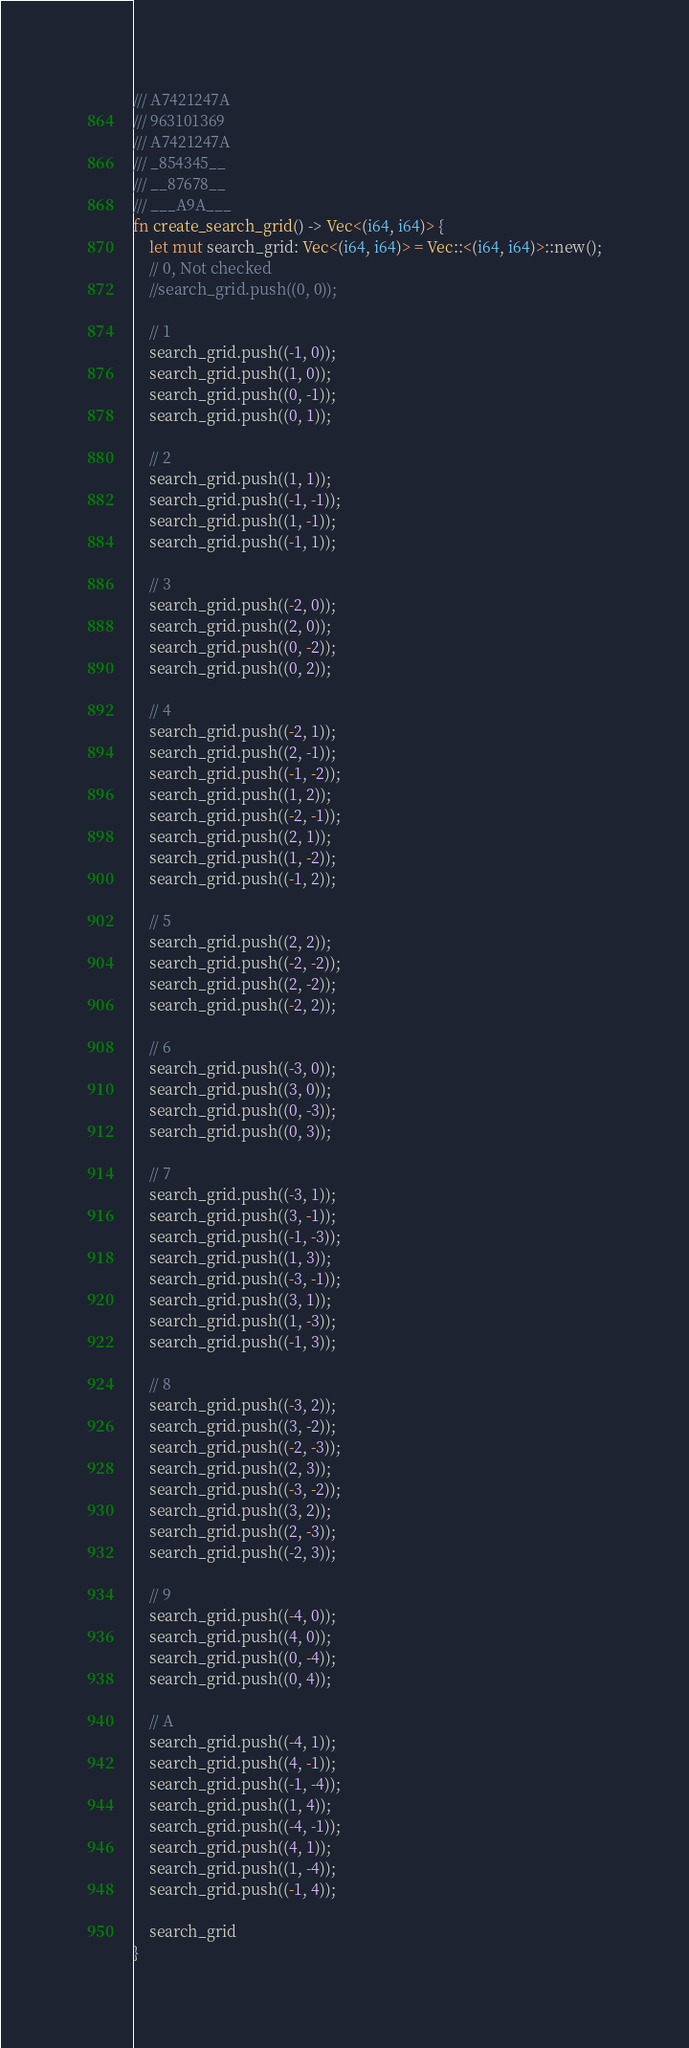Convert code to text. <code><loc_0><loc_0><loc_500><loc_500><_Rust_>/// A7421247A
/// 963101369
/// A7421247A
/// _854345__
/// __87678__
/// ___A9A___
fn create_search_grid() -> Vec<(i64, i64)> {
    let mut search_grid: Vec<(i64, i64)> = Vec::<(i64, i64)>::new();
    // 0, Not checked
    //search_grid.push((0, 0));

    // 1
    search_grid.push((-1, 0));
    search_grid.push((1, 0));
    search_grid.push((0, -1));
    search_grid.push((0, 1));

    // 2
    search_grid.push((1, 1));
    search_grid.push((-1, -1));
    search_grid.push((1, -1));
    search_grid.push((-1, 1));

    // 3
    search_grid.push((-2, 0));
    search_grid.push((2, 0));
    search_grid.push((0, -2));
    search_grid.push((0, 2));

    // 4
    search_grid.push((-2, 1));
    search_grid.push((2, -1));
    search_grid.push((-1, -2));
    search_grid.push((1, 2));
    search_grid.push((-2, -1));
    search_grid.push((2, 1));
    search_grid.push((1, -2));
    search_grid.push((-1, 2));

    // 5
    search_grid.push((2, 2));
    search_grid.push((-2, -2));
    search_grid.push((2, -2));
    search_grid.push((-2, 2));

    // 6
    search_grid.push((-3, 0));
    search_grid.push((3, 0));
    search_grid.push((0, -3));
    search_grid.push((0, 3));

    // 7
    search_grid.push((-3, 1));
    search_grid.push((3, -1));
    search_grid.push((-1, -3));
    search_grid.push((1, 3));
    search_grid.push((-3, -1));
    search_grid.push((3, 1));
    search_grid.push((1, -3));
    search_grid.push((-1, 3));

    // 8
    search_grid.push((-3, 2));
    search_grid.push((3, -2));
    search_grid.push((-2, -3));
    search_grid.push((2, 3));
    search_grid.push((-3, -2));
    search_grid.push((3, 2));
    search_grid.push((2, -3));
    search_grid.push((-2, 3));

    // 9
    search_grid.push((-4, 0));
    search_grid.push((4, 0));
    search_grid.push((0, -4));
    search_grid.push((0, 4));

    // A
    search_grid.push((-4, 1));
    search_grid.push((4, -1));
    search_grid.push((-1, -4));
    search_grid.push((1, 4));
    search_grid.push((-4, -1));
    search_grid.push((4, 1));
    search_grid.push((1, -4));
    search_grid.push((-1, 4));

    search_grid
}
</code> 